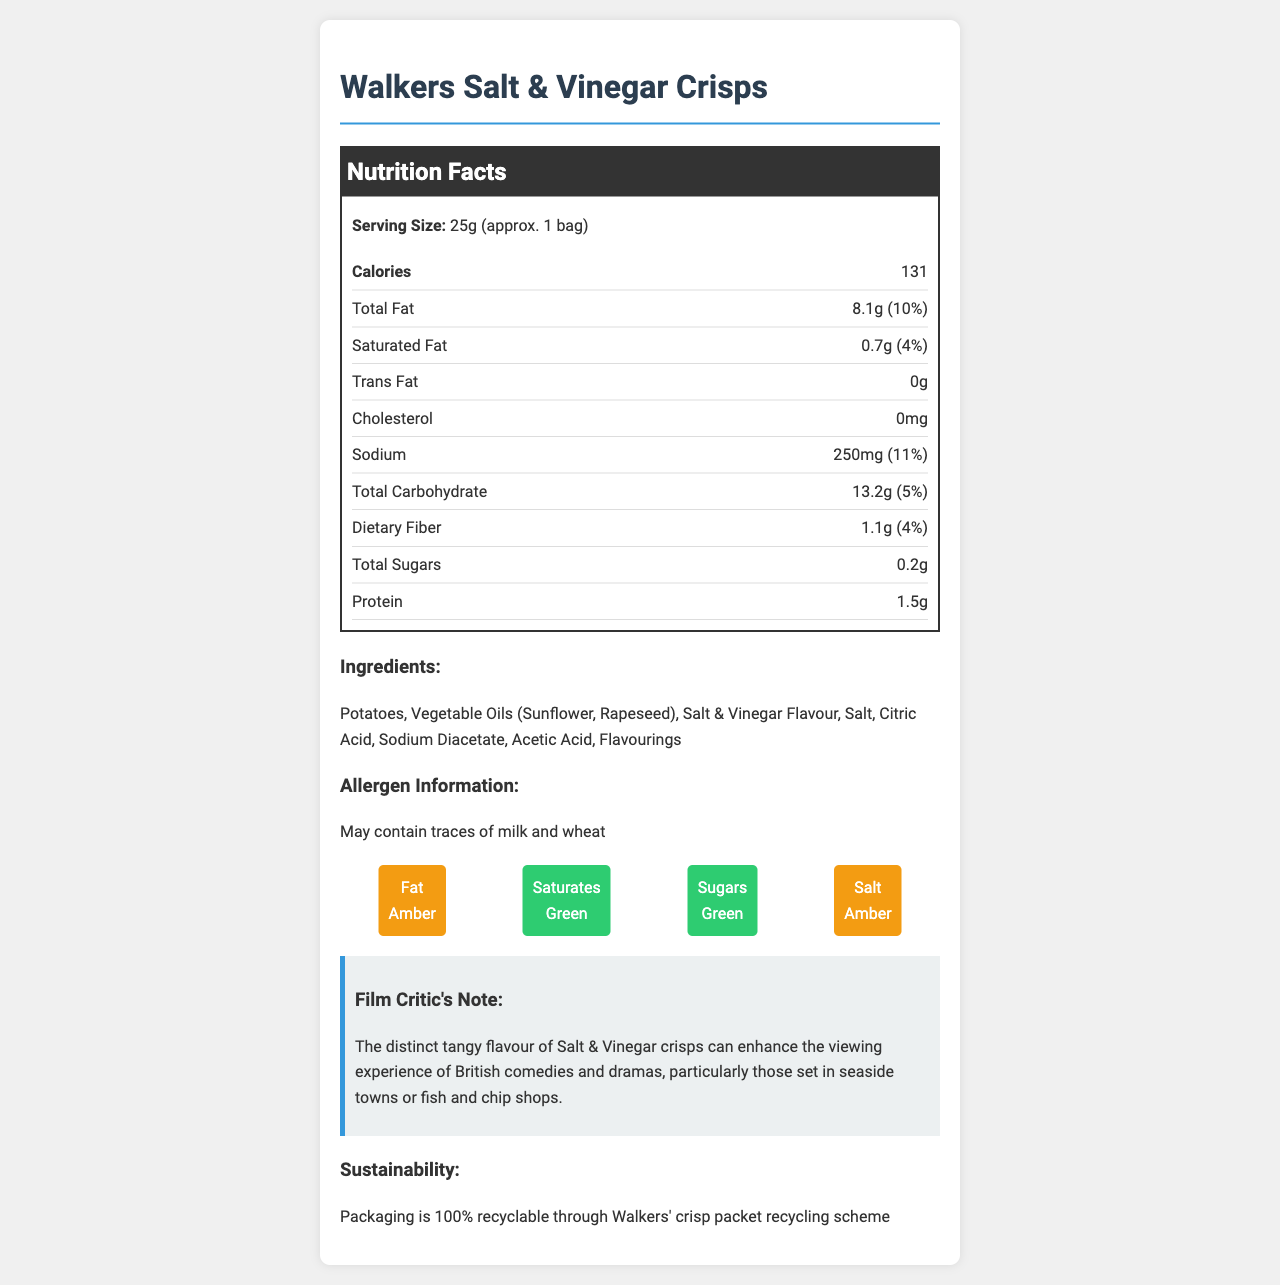what is the serving size? The serving size is mentioned at the beginning of the Nutrition Facts section.
Answer: 25g (approx. 1 bag) how many calories are in one serving? The number of calories per serving is listed in the Nutrition Facts section under "Calories".
Answer: 131 calories what is the total fat content per serving? The total fat content per serving is mentioned in the Nutrition Facts section under "Total Fat".
Answer: 8.1g what is the sodium content in one serving? The sodium content per serving is listed in the Nutrition Facts section under "Sodium".
Answer: 250mg which ingredient is listed first? The first ingredient listed in the Ingredients section is "Potatoes".
Answer: Potatoes what is the percentage of daily value for saturated fat per serving? The percentage of daily value for saturated fat is listed in the Nutrition Facts section under "Saturated Fat".
Answer: 4% does this product contain trans fat? Yes/No The Nutrition Facts section shows that the trans fat content is 0g.
Answer: No which of the following is not listed as an ingredient? A. Salt B. Potatoes C. Corn Oil D. Citric Acid The Ingredients section lists "Potatoes", "Salt", and "Citric Acid", but not "Corn Oil".
Answer: C. Corn Oil what is the total carbohydrate amount per serving? The total carbohydrate amount per serving is detailed in the Nutrition Facts section under "Total Carbohydrate".
Answer: 13.2g is there any added sugar in this product? The Nutrition Facts section shows that added sugars are 0g.
Answer: No which traffic light label is red for Walkers Salt & Vinegar Crisps? A. Fat B. Saturates C. Sugars D. All of the above The traffic light labels for fat, saturates, and sugars are amber, green, and green respectively.
Answer: None how much protein does one serving of the crisps contain? The Nutrition Facts section lists the protein content as 1.5g.
Answer: 1.5g what can be inferred about the Walkers company from this document? The document mentions in the Sustainability section that the packaging is 100% recyclable through Walkers' crisp packet recycling scheme.
Answer: They have a crisp packet recycling scheme how does the film critic describe the experience of eating these crisps during films? This observation is found in the "Film Critic's Note" section.
Answer: The tangy flavour enhances the viewing experience of British comedies and dramas, especially those set in seaside towns or fish and chip shops. what is the address of the manufacturer? The address of the manufacturer is found under the manufacturer information section.
Answer: Leicester, LE4 5ZY, United Kingdom what is the daily value percentage of calcium provided per serving? The daily value percentage for calcium is listed in the Nutrition Facts section as "1%".
Answer: 1% can the allergen information be confirmed visually from the document? The allergen information stating "May contain traces of milk and wheat" is listed under the Allergen Information section.
Answer: Yes what historical tidbit is given about Walkers crisps and British cinemas? This information is found in the "Cinema Trivia" section.
Answer: They have been a staple snack in British cinemas since the 1950s. summarize the main information provided in the document. The document summarizes the nutritional information, ingredients, allergen details, and additional notes regarding the crisps' compatibility with film watching, their history, and sustainability.
Answer: This document provides detailed nutrition facts for Walkers Salt & Vinegar Crisps, including calories, total fat, sodium, carbohydrates, protein, and other nutritional content. It also lists the ingredients and allergen information, describes the product's impact on film viewing, and mentions the company's recycling efforts and historical trivia. Walkers crisps are presented as a familiar and sustainable snack option at British cinemas. what benefits might Walkers' recycling scheme provide? The document mentions that Walkers' packaging is 100% recyclable through their recycling scheme but does not provide specific benefits or outcomes of this scheme.
Answer: Cannot be determined 